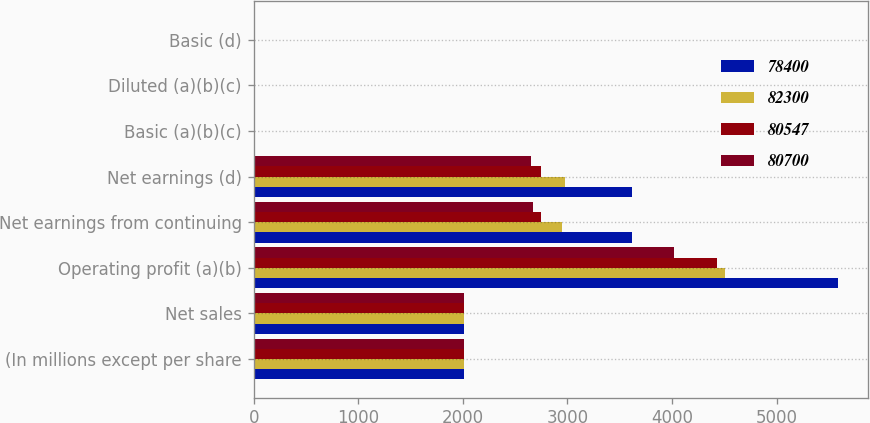Convert chart. <chart><loc_0><loc_0><loc_500><loc_500><stacked_bar_chart><ecel><fcel>(In millions except per share<fcel>Net sales<fcel>Operating profit (a)(b)<fcel>Net earnings from continuing<fcel>Net earnings (d)<fcel>Basic (a)(b)(c)<fcel>Diluted (a)(b)(c)<fcel>Basic (d)<nl><fcel>78400<fcel>2014<fcel>2012.5<fcel>5592<fcel>3614<fcel>3614<fcel>11.41<fcel>11.21<fcel>11.41<nl><fcel>82300<fcel>2013<fcel>2012.5<fcel>4505<fcel>2950<fcel>2981<fcel>9.19<fcel>9.04<fcel>9.29<nl><fcel>80547<fcel>2012<fcel>2012.5<fcel>4434<fcel>2745<fcel>2745<fcel>8.48<fcel>8.36<fcel>8.48<nl><fcel>80700<fcel>2011<fcel>2012.5<fcel>4020<fcel>2667<fcel>2655<fcel>7.94<fcel>7.85<fcel>7.9<nl></chart> 